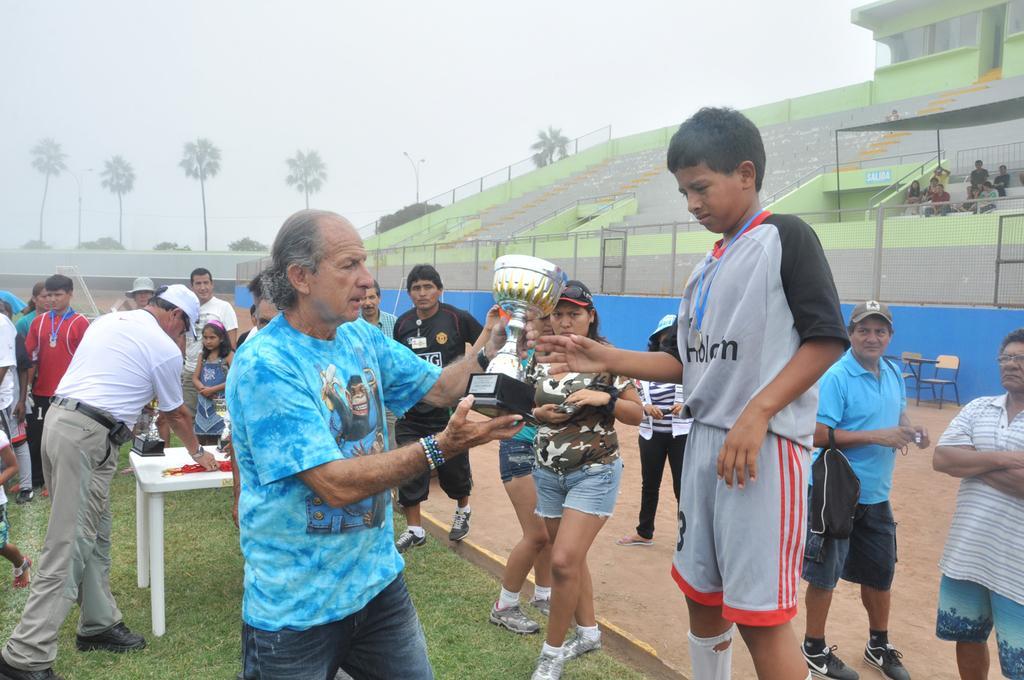Please provide a concise description of this image. In this picture we can observe an old man wearing blue color T shirt presenting a cup to the player. In the background there is a white color table. There are some people standing. There are men and women in this picture. There is a fence. In the background there is a stadium and some trees. We can observe a sky. 